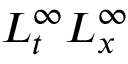Convert formula to latex. <formula><loc_0><loc_0><loc_500><loc_500>L _ { t } ^ { \infty } L _ { x } ^ { \infty }</formula> 